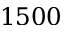<formula> <loc_0><loc_0><loc_500><loc_500>1 5 0 0</formula> 